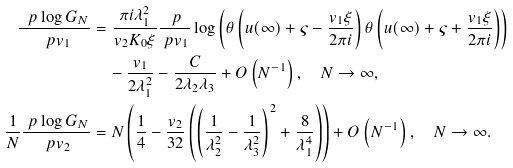Convert formula to latex. <formula><loc_0><loc_0><loc_500><loc_500>\frac { \ p \log G _ { N } } { \ p v _ { 1 } } & = \frac { \pi i \lambda _ { 1 } ^ { 2 } } { v _ { 2 } K _ { 0 } \xi } \frac { \ p } { \ p v _ { 1 } } \log \left ( \theta \left ( u ( \infty ) + \varsigma - \frac { v _ { 1 } \xi } { 2 \pi i } \right ) \theta \left ( u ( \infty ) + \varsigma + \frac { v _ { 1 } \xi } { 2 \pi i } \right ) \right ) \\ & \quad - \frac { v _ { 1 } } { 2 \lambda _ { 1 } ^ { 2 } } - \frac { C } { 2 \lambda _ { 2 } \lambda _ { 3 } } + O \left ( N ^ { - 1 } \right ) , \quad N \to \infty , \\ \frac { 1 } { N } \frac { \ p \log G _ { N } } { \ p v _ { 2 } } & = N \left ( \frac { 1 } { 4 } - \frac { v _ { 2 } } { 3 2 } \left ( \left ( \frac { 1 } { \lambda _ { 2 } ^ { 2 } } - \frac { 1 } { \lambda _ { 3 } ^ { 2 } } \right ) ^ { 2 } + \frac { 8 } { \lambda _ { 1 } ^ { 4 } } \right ) \right ) + O \left ( N ^ { - 1 } \right ) , \quad N \to \infty .</formula> 